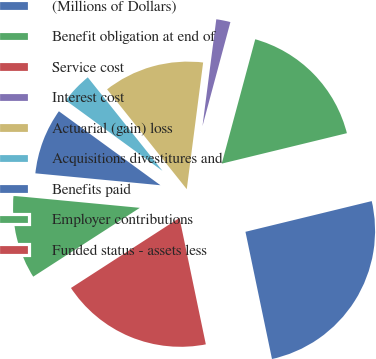<chart> <loc_0><loc_0><loc_500><loc_500><pie_chart><fcel>(Millions of Dollars)<fcel>Benefit obligation at end of<fcel>Service cost<fcel>Interest cost<fcel>Actuarial (gain) loss<fcel>Acquisitions divestitures and<fcel>Benefits paid<fcel>Employer contributions<fcel>Funded status - assets less<nl><fcel>25.53%<fcel>17.02%<fcel>0.01%<fcel>2.13%<fcel>12.77%<fcel>4.26%<fcel>8.51%<fcel>10.64%<fcel>19.15%<nl></chart> 